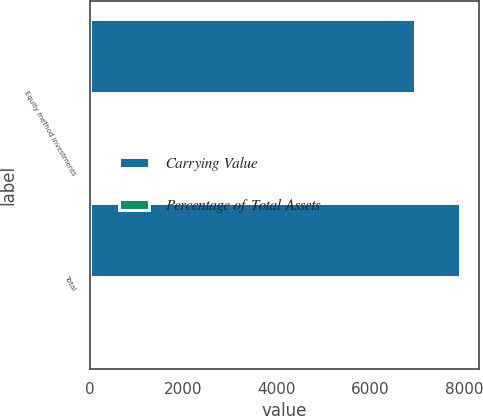Convert chart to OTSL. <chart><loc_0><loc_0><loc_500><loc_500><stacked_bar_chart><ecel><fcel>Equity method investments<fcel>Total<nl><fcel>Carrying Value<fcel>6954<fcel>7918<nl><fcel>Percentage of Total Assets<fcel>10<fcel>11<nl></chart> 